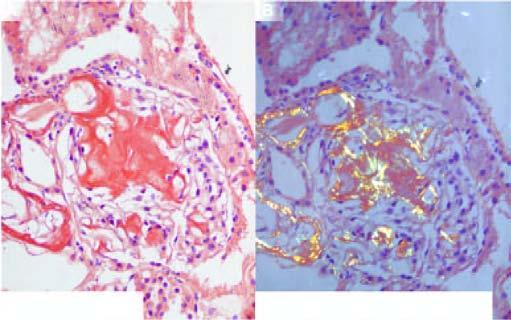re the amyloid deposits mainly in the glomerular capillary tuft stain red-pink congophilia?
Answer the question using a single word or phrase. Yes 